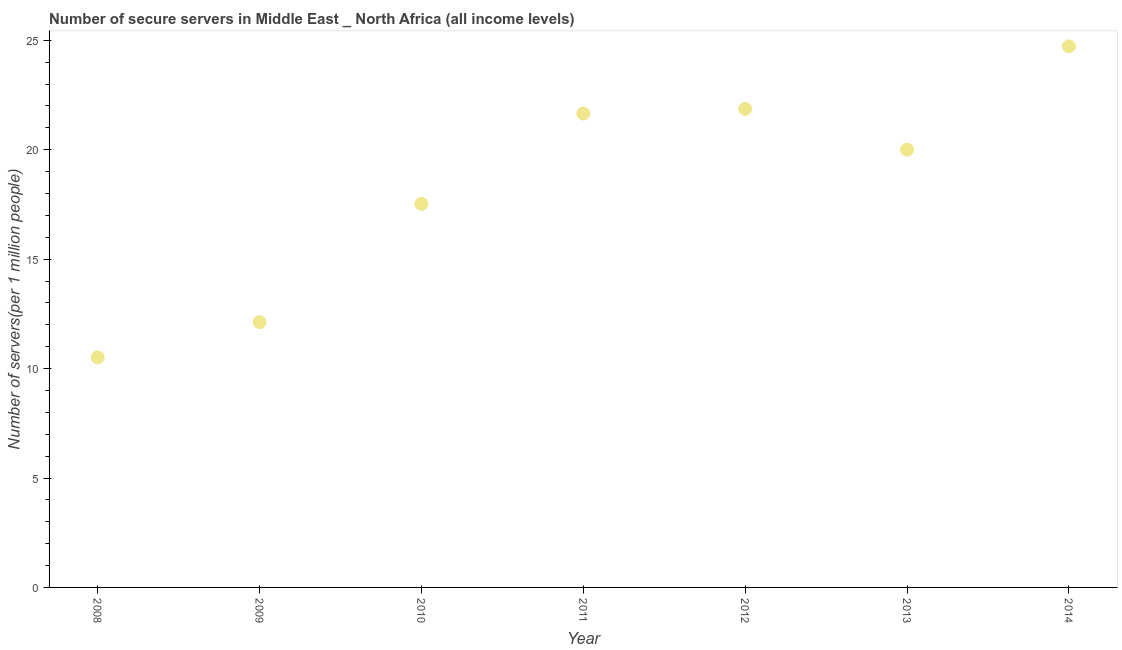What is the number of secure internet servers in 2009?
Make the answer very short. 12.12. Across all years, what is the maximum number of secure internet servers?
Make the answer very short. 24.72. Across all years, what is the minimum number of secure internet servers?
Your answer should be compact. 10.51. In which year was the number of secure internet servers maximum?
Offer a very short reply. 2014. What is the sum of the number of secure internet servers?
Keep it short and to the point. 128.41. What is the difference between the number of secure internet servers in 2009 and 2011?
Your answer should be compact. -9.53. What is the average number of secure internet servers per year?
Your response must be concise. 18.34. What is the median number of secure internet servers?
Ensure brevity in your answer.  20. What is the ratio of the number of secure internet servers in 2008 to that in 2011?
Offer a terse response. 0.49. Is the number of secure internet servers in 2009 less than that in 2012?
Your response must be concise. Yes. What is the difference between the highest and the second highest number of secure internet servers?
Your answer should be very brief. 2.86. Is the sum of the number of secure internet servers in 2008 and 2009 greater than the maximum number of secure internet servers across all years?
Provide a short and direct response. No. What is the difference between the highest and the lowest number of secure internet servers?
Your answer should be compact. 14.21. In how many years, is the number of secure internet servers greater than the average number of secure internet servers taken over all years?
Provide a succinct answer. 4. Does the number of secure internet servers monotonically increase over the years?
Your answer should be very brief. No. How many years are there in the graph?
Offer a very short reply. 7. Does the graph contain any zero values?
Make the answer very short. No. What is the title of the graph?
Your response must be concise. Number of secure servers in Middle East _ North Africa (all income levels). What is the label or title of the Y-axis?
Provide a short and direct response. Number of servers(per 1 million people). What is the Number of servers(per 1 million people) in 2008?
Keep it short and to the point. 10.51. What is the Number of servers(per 1 million people) in 2009?
Offer a very short reply. 12.12. What is the Number of servers(per 1 million people) in 2010?
Offer a very short reply. 17.53. What is the Number of servers(per 1 million people) in 2011?
Your answer should be very brief. 21.65. What is the Number of servers(per 1 million people) in 2012?
Offer a very short reply. 21.87. What is the Number of servers(per 1 million people) in 2013?
Your response must be concise. 20. What is the Number of servers(per 1 million people) in 2014?
Your answer should be compact. 24.72. What is the difference between the Number of servers(per 1 million people) in 2008 and 2009?
Provide a short and direct response. -1.61. What is the difference between the Number of servers(per 1 million people) in 2008 and 2010?
Provide a short and direct response. -7.02. What is the difference between the Number of servers(per 1 million people) in 2008 and 2011?
Keep it short and to the point. -11.14. What is the difference between the Number of servers(per 1 million people) in 2008 and 2012?
Make the answer very short. -11.36. What is the difference between the Number of servers(per 1 million people) in 2008 and 2013?
Keep it short and to the point. -9.49. What is the difference between the Number of servers(per 1 million people) in 2008 and 2014?
Provide a succinct answer. -14.21. What is the difference between the Number of servers(per 1 million people) in 2009 and 2010?
Give a very brief answer. -5.41. What is the difference between the Number of servers(per 1 million people) in 2009 and 2011?
Provide a short and direct response. -9.53. What is the difference between the Number of servers(per 1 million people) in 2009 and 2012?
Your response must be concise. -9.74. What is the difference between the Number of servers(per 1 million people) in 2009 and 2013?
Your response must be concise. -7.88. What is the difference between the Number of servers(per 1 million people) in 2009 and 2014?
Keep it short and to the point. -12.6. What is the difference between the Number of servers(per 1 million people) in 2010 and 2011?
Your answer should be very brief. -4.12. What is the difference between the Number of servers(per 1 million people) in 2010 and 2012?
Make the answer very short. -4.34. What is the difference between the Number of servers(per 1 million people) in 2010 and 2013?
Your response must be concise. -2.47. What is the difference between the Number of servers(per 1 million people) in 2010 and 2014?
Your answer should be very brief. -7.19. What is the difference between the Number of servers(per 1 million people) in 2011 and 2012?
Your answer should be compact. -0.21. What is the difference between the Number of servers(per 1 million people) in 2011 and 2013?
Make the answer very short. 1.65. What is the difference between the Number of servers(per 1 million people) in 2011 and 2014?
Offer a terse response. -3.07. What is the difference between the Number of servers(per 1 million people) in 2012 and 2013?
Your answer should be very brief. 1.87. What is the difference between the Number of servers(per 1 million people) in 2012 and 2014?
Your response must be concise. -2.86. What is the difference between the Number of servers(per 1 million people) in 2013 and 2014?
Offer a terse response. -4.72. What is the ratio of the Number of servers(per 1 million people) in 2008 to that in 2009?
Your answer should be very brief. 0.87. What is the ratio of the Number of servers(per 1 million people) in 2008 to that in 2011?
Provide a short and direct response. 0.48. What is the ratio of the Number of servers(per 1 million people) in 2008 to that in 2012?
Keep it short and to the point. 0.48. What is the ratio of the Number of servers(per 1 million people) in 2008 to that in 2013?
Offer a terse response. 0.53. What is the ratio of the Number of servers(per 1 million people) in 2008 to that in 2014?
Offer a terse response. 0.42. What is the ratio of the Number of servers(per 1 million people) in 2009 to that in 2010?
Make the answer very short. 0.69. What is the ratio of the Number of servers(per 1 million people) in 2009 to that in 2011?
Ensure brevity in your answer.  0.56. What is the ratio of the Number of servers(per 1 million people) in 2009 to that in 2012?
Your response must be concise. 0.55. What is the ratio of the Number of servers(per 1 million people) in 2009 to that in 2013?
Your response must be concise. 0.61. What is the ratio of the Number of servers(per 1 million people) in 2009 to that in 2014?
Make the answer very short. 0.49. What is the ratio of the Number of servers(per 1 million people) in 2010 to that in 2011?
Offer a very short reply. 0.81. What is the ratio of the Number of servers(per 1 million people) in 2010 to that in 2012?
Give a very brief answer. 0.8. What is the ratio of the Number of servers(per 1 million people) in 2010 to that in 2013?
Your answer should be very brief. 0.88. What is the ratio of the Number of servers(per 1 million people) in 2010 to that in 2014?
Offer a very short reply. 0.71. What is the ratio of the Number of servers(per 1 million people) in 2011 to that in 2012?
Keep it short and to the point. 0.99. What is the ratio of the Number of servers(per 1 million people) in 2011 to that in 2013?
Your answer should be compact. 1.08. What is the ratio of the Number of servers(per 1 million people) in 2011 to that in 2014?
Offer a terse response. 0.88. What is the ratio of the Number of servers(per 1 million people) in 2012 to that in 2013?
Your answer should be very brief. 1.09. What is the ratio of the Number of servers(per 1 million people) in 2012 to that in 2014?
Offer a terse response. 0.88. What is the ratio of the Number of servers(per 1 million people) in 2013 to that in 2014?
Provide a short and direct response. 0.81. 